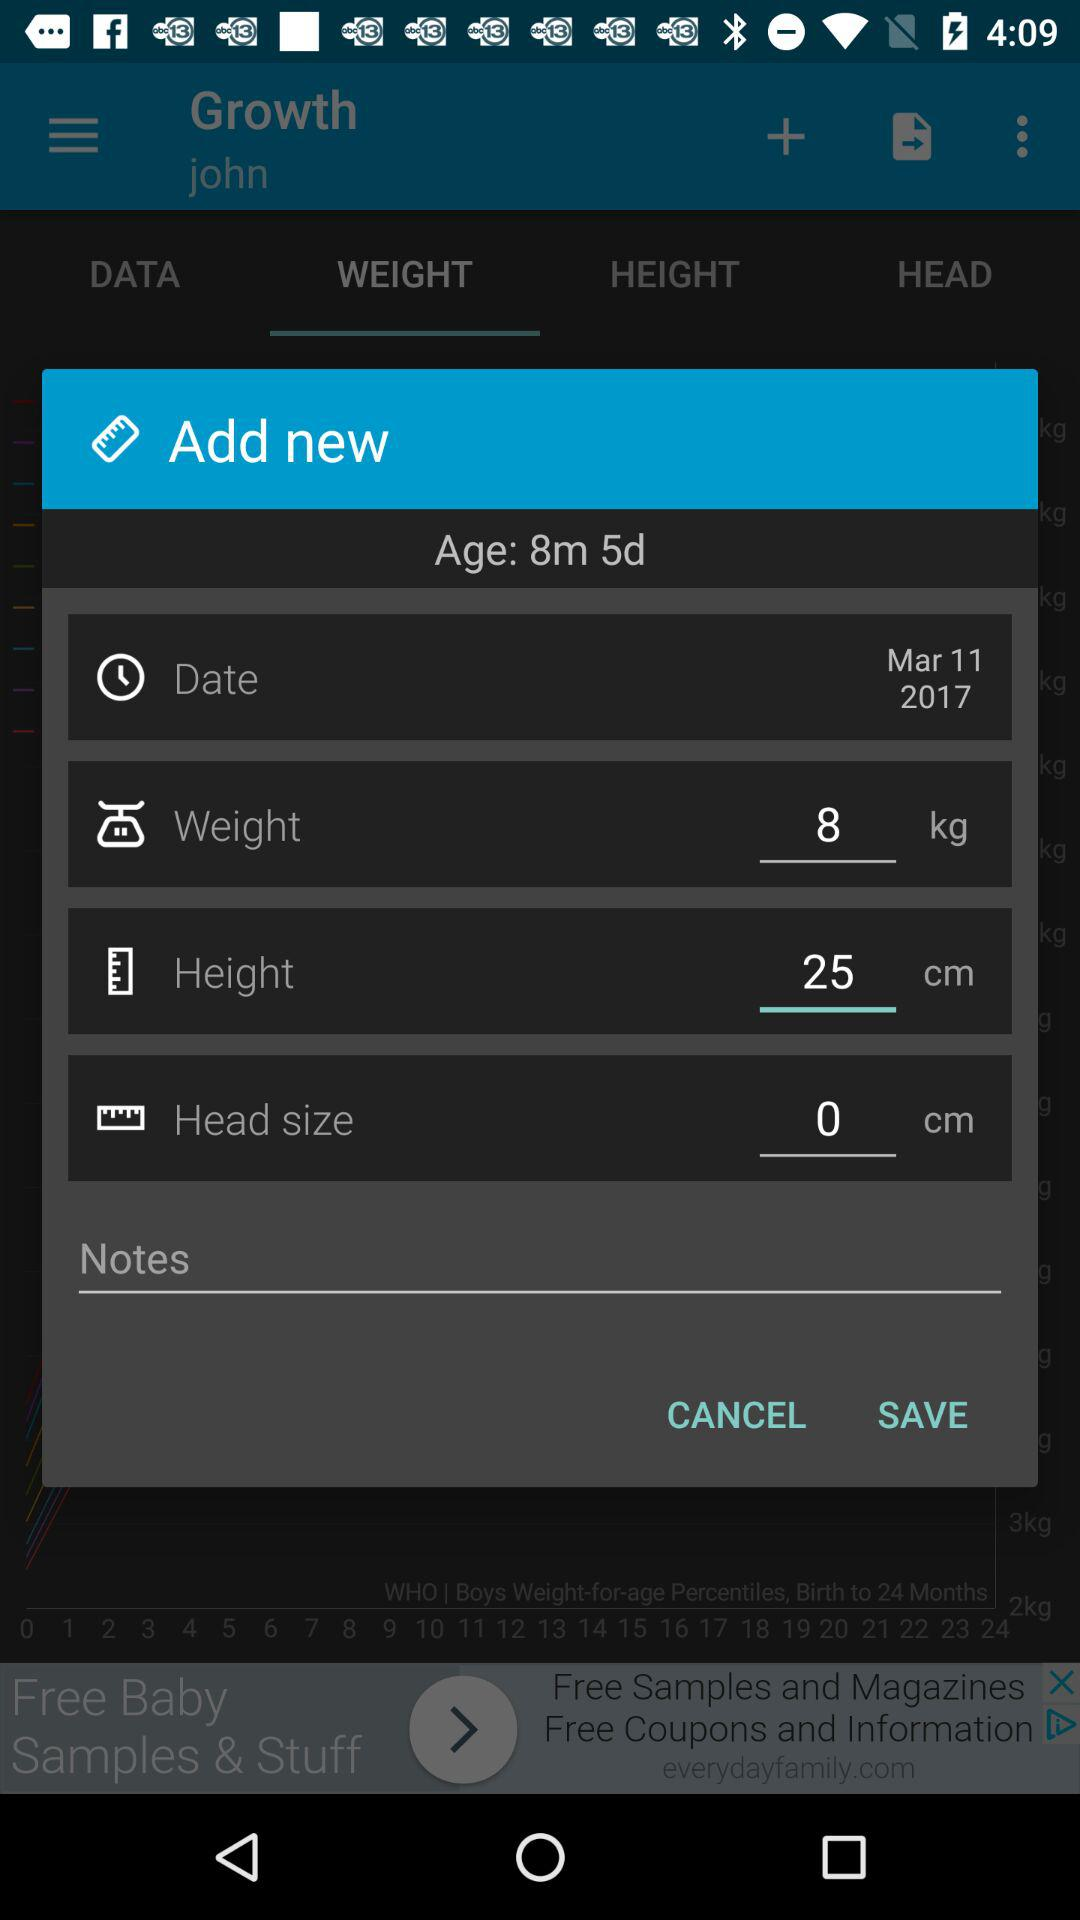What is the selected date? The selected date is March 11, 2017. 